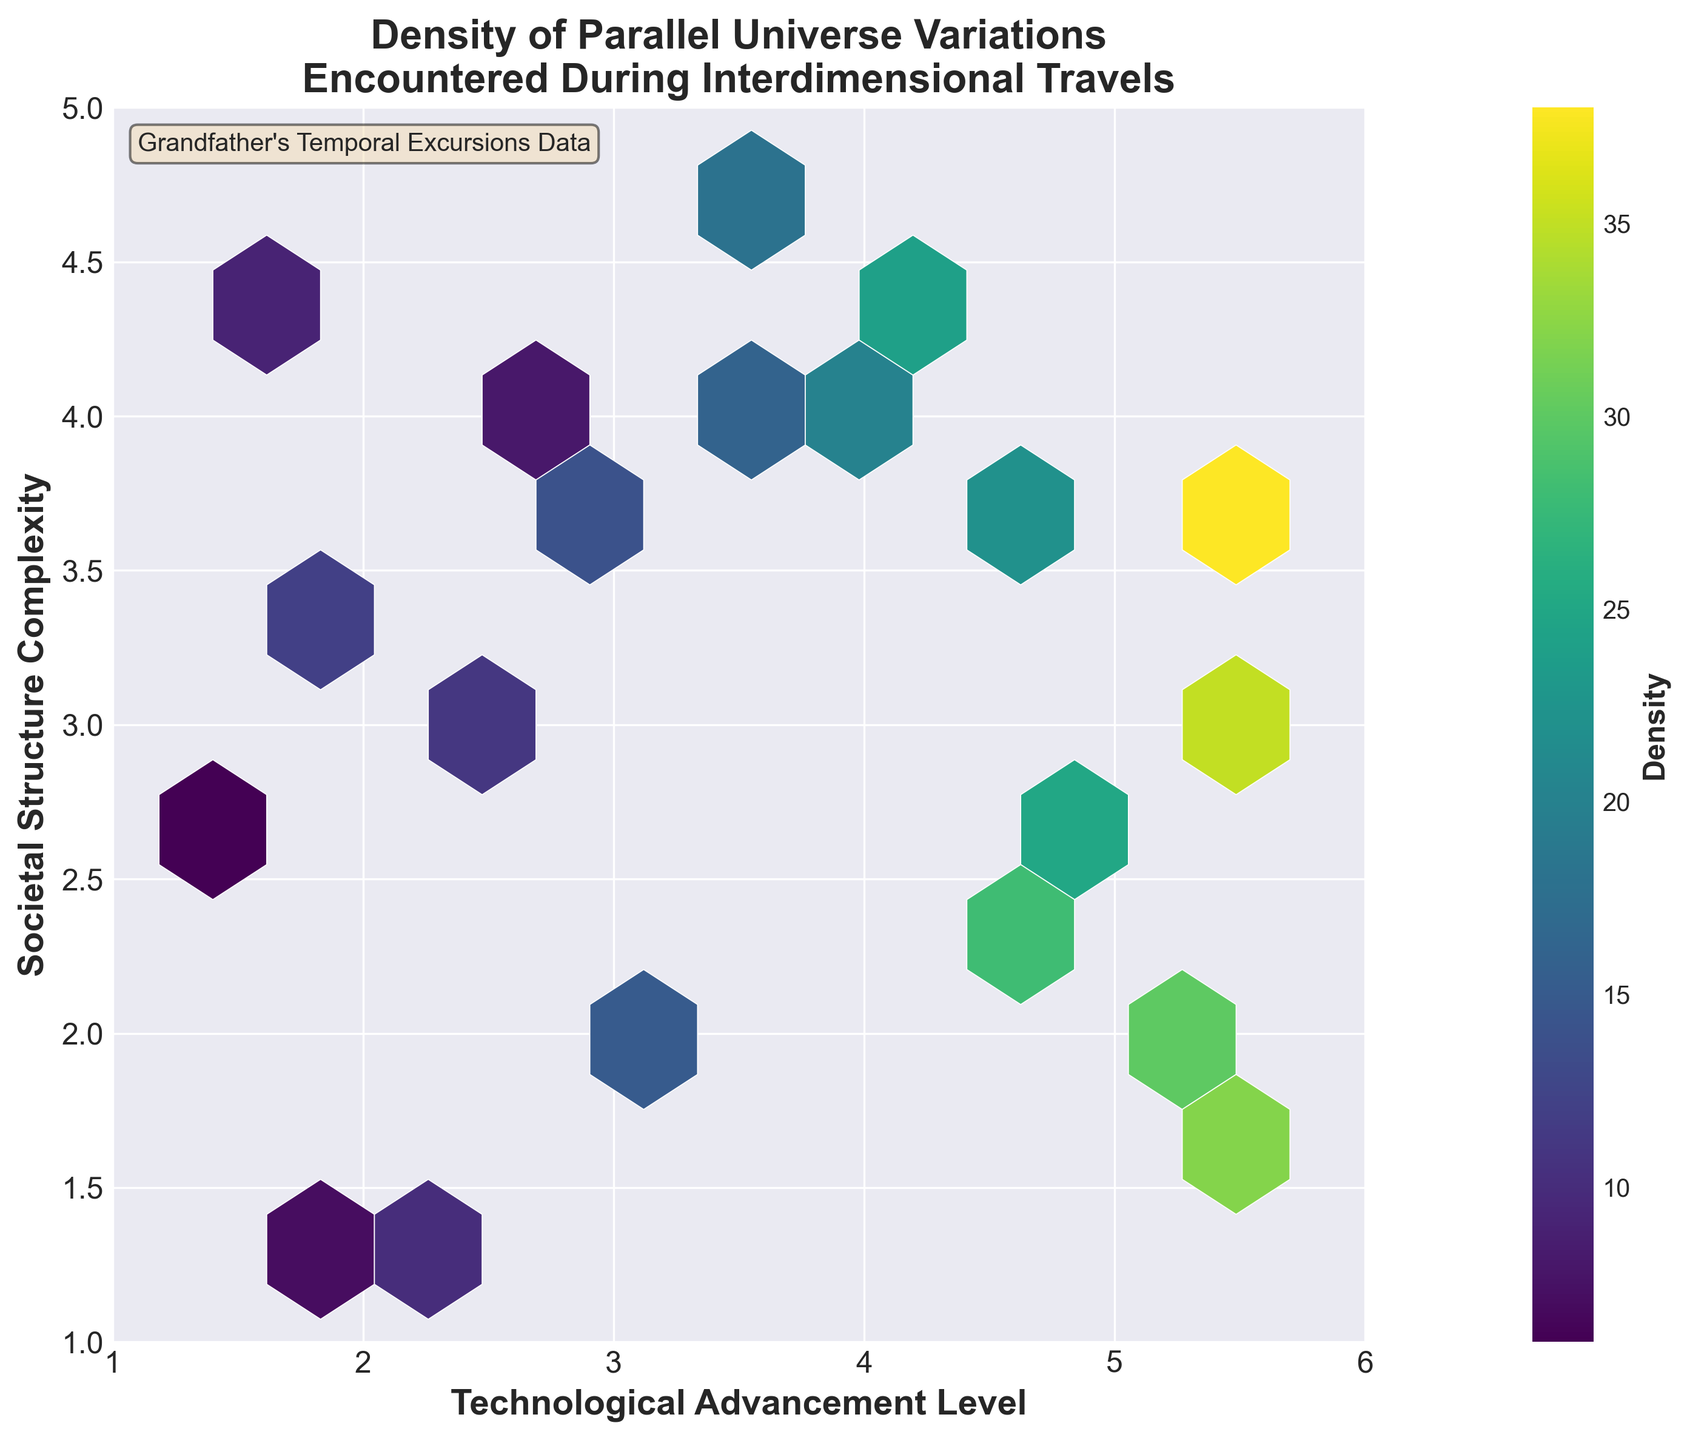What's the title of the plot? The title of the plot can be found at the top center of the figure. It provides a summarized description of what the plot represents.
Answer: Density of Parallel Universe Variations Encountered During Interdimensional Travels What do the x and y axes represent? The labels on the x and y axes indicate what each axis represents. The x-axis represents "Technological Advancement Level" and the y-axis represents "Societal Structure Complexity."
Answer: Technological Advancement Level and Societal Structure Complexity, respectively What information is shown by the color bar? The color bar, typically located on the right side of the plot, shows the gradient of colors corresponding to the density values in the hexbin plot. This helps us understand how density values are distributed visually.
Answer: Density In which range of technological advancement levels is the highest density of parallel universe variations found? To find this, note which hexagons have the highest color intensity and refer to their position on the x-axis. The color bar helps identify the highest density values, located on the right side of the plot.
Answer: Between 5.0 and 5.5 Which range on the y-axis (societal structure complexity) shows the least variation in density? By observing the y-axis and looking for the least color variation or blank hexagons, you can determine the range.
Answer: 1.0 to 2.0 What's the difference in density between the highest density hexagon and the lowest density hexagon? Identify the hexagons with the highest and lowest color intensities using the color bar. Note their corresponding density values and calculate the difference. The highest density indicated by the color bar is 38 and the lowest is 6.
Answer: 38 - 6 = 32 Is there a general trend observed between technological advancement and societal structure complexity based on the plot? By scanning the plot diagonally, we can look to see if there is a visible trend in color intensity indicating a relationship between the two variables.
Answer: Yes, higher technological advancement levels generally correlate with increased societal structure complexity Which regions of the plot show outliers in terms of density? Identify the regions that deviate significantly from the general trend or have isolated high/low density hexagons compared to surrounding areas.
Answer: Regions around (5.5,3.2) and (5.7,3.6) show significantly high density Are there any notable clusters of parallel universe variations? If so, where? Clusters can be identified by looking for areas with tightly grouped hexagons of similar high color intensity.
Answer: Yes, clusters are noticeable in the ranges of (4.5, 3.8), (5.1, 1.9), (4.9, 2.8) Do the hexagons appear to be more densely populated in any specific corner or side of the plot? Inspect the plot to see if there's a concentration of hexagons near any particular edge or corner.
Answer: Yes, the bottom-right corner near the higher values of technological advancement 